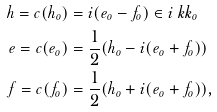Convert formula to latex. <formula><loc_0><loc_0><loc_500><loc_500>h = c ( h _ { o } ) & = i ( e _ { o } - f _ { o } ) \in i \ k k _ { o } \\ e = c ( e _ { o } ) & = \frac { 1 } { 2 } ( h _ { o } - i ( e _ { o } + f _ { o } ) ) \\ f = c ( f _ { o } ) & = \frac { 1 } { 2 } ( h _ { o } + i ( e _ { o } + f _ { o } ) ) ,</formula> 